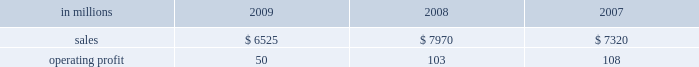Higher in the first half of the year , but declined dur- ing the second half of the year reflecting the pass- through to customers of lower resin input costs .
However , average margins benefitted from a more favorable mix of products sold .
Raw material costs were lower , primarily for resins .
Freight costs were also favorable , while operating costs increased .
Shorewood sales volumes in 2009 declined from 2008 levels reflecting weaker demand in the home entertainment segment and a decrease in tobacco segment orders as customers have shifted pro- duction outside of the united states , partially offset by higher shipments in the consumer products segment .
Average sales margins improved reflecting a more favorable mix of products sold .
Raw material costs were higher , but were partially offset by lower freight costs .
Operating costs were favorable , reflect- ing benefits from business reorganization and cost reduction actions taken in 2008 and 2009 .
Charges to restructure operations totaled $ 7 million in 2009 and $ 30 million in 2008 .
Entering 2010 , coated paperboard sales volumes are expected to increase , while average sales price real- izations should be comparable to 2009 fourth-quarter levels .
Raw material costs are expected to be sig- nificantly higher for wood , energy and chemicals , but planned maintenance downtime costs will decrease .
Foodservice sales volumes are expected to remain about flat , but average sales price realizations should improve slightly .
Input costs for resins should be higher , but will be partially offset by lower costs for bleached board .
Shorewood sales volumes are expected to decline reflecting seasonal decreases in home entertainment segment shipments .
Operating costs are expected to be favorable reflecting the benefits of business reorganization efforts .
European consumer packaging net sales in 2009 were $ 315 million compared with $ 300 million in 2008 and $ 280 million in 2007 .
Operating earnings in 2009 of $ 66 million increased from $ 22 million in 2008 and $ 30 million in 2007 .
Sales volumes in 2009 were higher than in 2008 reflecting increased ship- ments to export markets .
Average sales margins declined due to increased shipments to lower- margin export markets and lower average sales prices in western europe .
Entering 2010 , sales volumes for the first quarter are expected to remain strong .
Average margins should improve reflecting increased sales price realizations and a more favorable geographic mix of products sold .
Input costs are expected to be higher due to increased wood prices in poland and annual energy tariff increases in russia .
Asian consumer packaging net sales were $ 545 million in 2009 compared with $ 390 million in 2008 and $ 330 million in 2007 .
Operating earnings in 2009 were $ 24 million compared with a loss of $ 13 million in 2008 and earnings of $ 12 million in 2007 .
The improved operating earnings in 2009 reflect increased sales volumes , higher average sales mar- gins and lower input costs , primarily for chemicals .
The loss in 2008 was primarily due to a $ 12 million charge to revalue pulp inventories at our shandong international paper and sun coated paperboard co. , ltd .
Joint venture and start-up costs associated with the joint venture 2019s new folding box board paper machine .
Distribution xpedx , our distribution business , markets a diverse array of products and supply chain services to cus- tomers in many business segments .
Customer demand is generally sensitive to changes in general economic conditions , although the commercial printing segment is also dependent on consumer advertising and promotional spending .
Distribution 2019s margins are relatively stable across an economic cycle .
Providing customers with the best choice and value in both products and supply chain services is a key competitive factor .
Additionally , efficient customer service , cost-effective logistics and focused working capital management are key factors in this segment 2019s profitability .
Distribution in millions 2009 2008 2007 .
Distribution 2019s 2009 annual sales decreased 18% ( 18 % ) from 2008 and 11% ( 11 % ) from 2007 while operating profits in 2009 decreased 51% ( 51 % ) compared with 2008 and 54% ( 54 % ) compared with 2007 .
Annual sales of printing papers and graphic arts supplies and equipment totaled $ 4.1 billion in 2009 compared with $ 5.2 billion in 2008 and $ 4.7 billion in 2007 , reflecting weak economic conditions in 2009 .
Trade margins as a percent of sales for printing papers increased from 2008 but decreased from 2007 due to a higher mix of lower margin direct ship- ments from manufacturers .
Revenue from packaging products was $ 1.3 billion in 2009 compared with $ 1.7 billion in 2008 and $ 1.5 billion in 2007 .
Trade margins as a percent of sales for packaging products were higher than in the past two years reflecting an improved product and service mix .
Facility supplies annual revenue was $ 1.1 billion in 2009 , essentially .
What was the percentage increase in annual sales of printing papers and graphic arts supplies and equipment from 2007 to 2008? 
Computations: ((5.2 - 4.7) / 4.7)
Answer: 0.10638. 